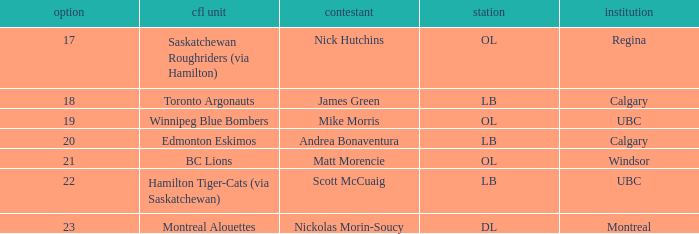What position is the player who went to Regina?  OL. 